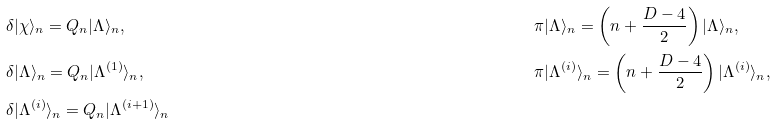Convert formula to latex. <formula><loc_0><loc_0><loc_500><loc_500>& \delta | \chi \rangle _ { n } = Q _ { n } | \Lambda \rangle _ { n } , & & \pi | \Lambda \rangle _ { n } = \left ( n + \frac { D - 4 } { 2 } \right ) | \Lambda \rangle _ { n } , \\ & \delta | \Lambda \rangle _ { n } = Q _ { n } | \Lambda ^ { ( 1 ) } \rangle _ { n } , & & \pi | \Lambda ^ { ( i ) } \rangle _ { n } = \left ( n + \frac { D - 4 } { 2 } \right ) | \Lambda ^ { ( i ) } \rangle _ { n } , \\ & \delta | \Lambda ^ { ( i ) } \rangle _ { n } = Q _ { n } | \Lambda ^ { ( i + 1 ) } \rangle _ { n }</formula> 